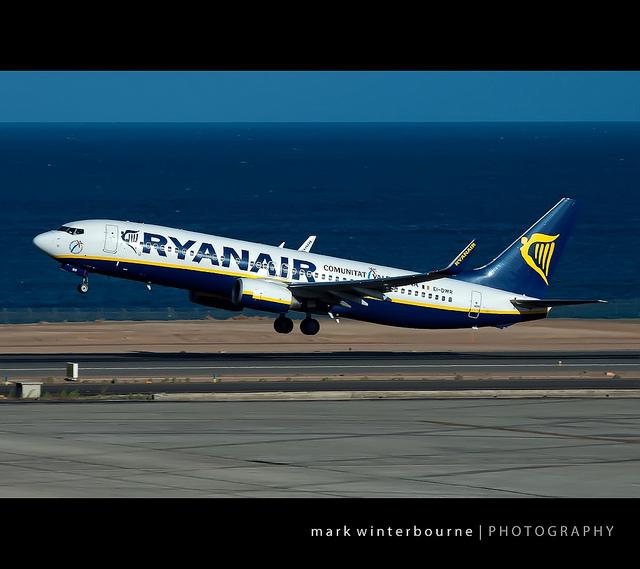Is this a US based airline?
Short answer required. No. What is the plane flying over?
Keep it brief. Runway. Which airline is this?
Give a very brief answer. Ryanair. Is it raining in the picture?
Concise answer only. No. Is the plane landing?
Short answer required. No. 